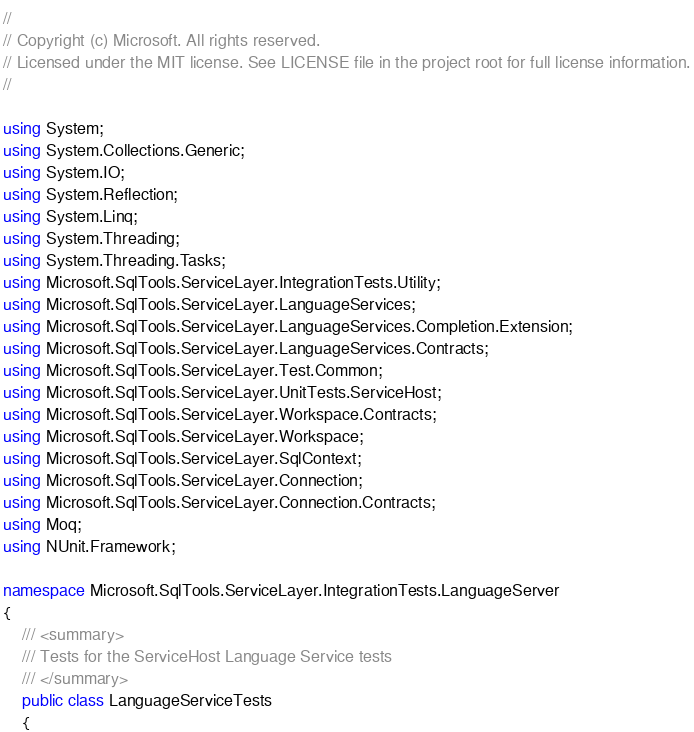Convert code to text. <code><loc_0><loc_0><loc_500><loc_500><_C#_>//
// Copyright (c) Microsoft. All rights reserved.
// Licensed under the MIT license. See LICENSE file in the project root for full license information.
//

using System;
using System.Collections.Generic;
using System.IO;
using System.Reflection;
using System.Linq;
using System.Threading;
using System.Threading.Tasks;
using Microsoft.SqlTools.ServiceLayer.IntegrationTests.Utility;
using Microsoft.SqlTools.ServiceLayer.LanguageServices;
using Microsoft.SqlTools.ServiceLayer.LanguageServices.Completion.Extension;
using Microsoft.SqlTools.ServiceLayer.LanguageServices.Contracts;
using Microsoft.SqlTools.ServiceLayer.Test.Common;
using Microsoft.SqlTools.ServiceLayer.UnitTests.ServiceHost;
using Microsoft.SqlTools.ServiceLayer.Workspace.Contracts;
using Microsoft.SqlTools.ServiceLayer.Workspace;
using Microsoft.SqlTools.ServiceLayer.SqlContext;
using Microsoft.SqlTools.ServiceLayer.Connection;
using Microsoft.SqlTools.ServiceLayer.Connection.Contracts;
using Moq;
using NUnit.Framework;

namespace Microsoft.SqlTools.ServiceLayer.IntegrationTests.LanguageServer
{
    /// <summary>
    /// Tests for the ServiceHost Language Service tests
    /// </summary>
    public class LanguageServiceTests
    {</code> 